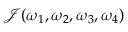Convert formula to latex. <formula><loc_0><loc_0><loc_500><loc_500>\mathcal { J } ( \omega _ { 1 } , \omega _ { 2 } , \omega _ { 3 } , \omega _ { 4 } )</formula> 